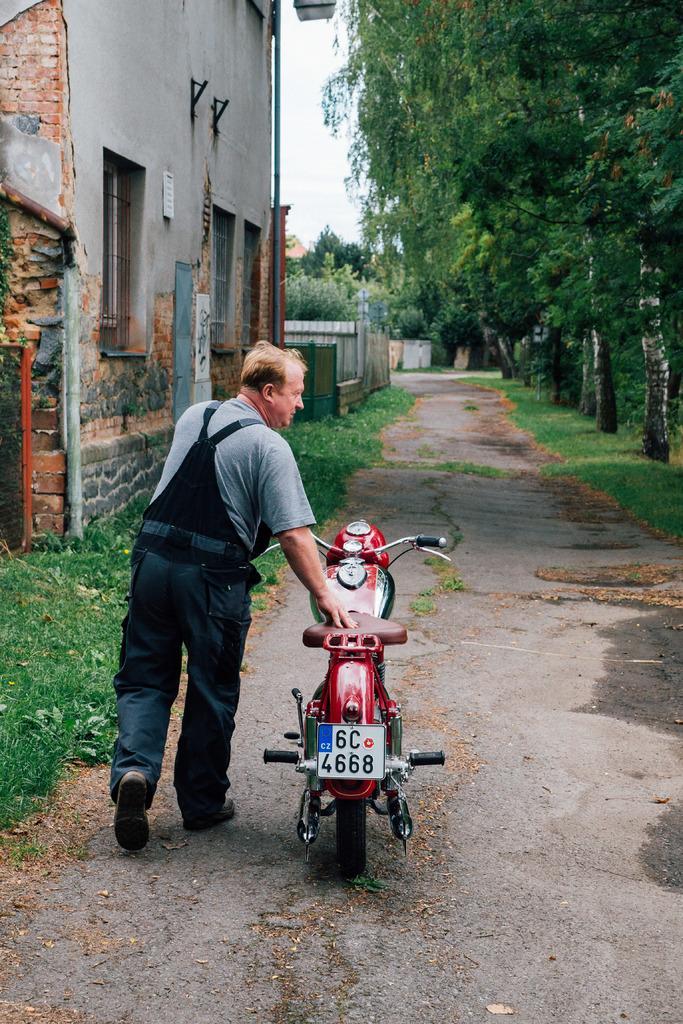Could you give a brief overview of what you see in this image? In this picture we can see a man walking and holding a bike, on the left side there is a building, we can see grass at the bottom, on the right side there are trees, we can see the sky at the top of the picture. 